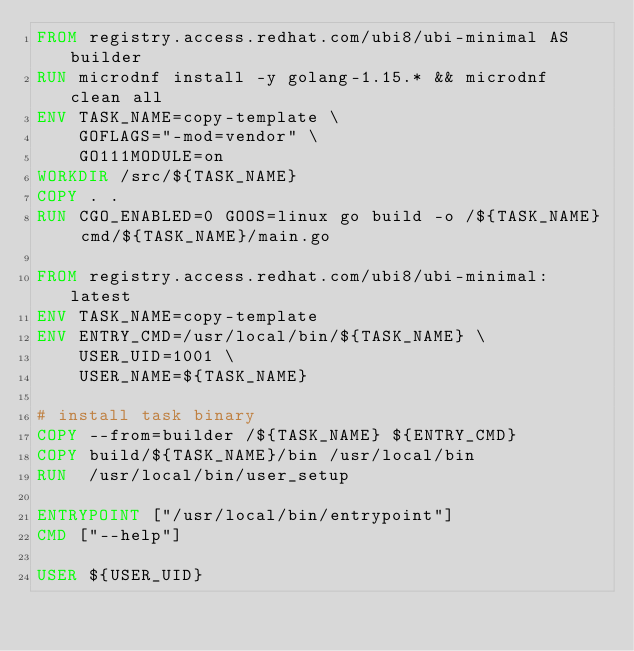Convert code to text. <code><loc_0><loc_0><loc_500><loc_500><_Dockerfile_>FROM registry.access.redhat.com/ubi8/ubi-minimal AS builder
RUN microdnf install -y golang-1.15.* && microdnf clean all
ENV TASK_NAME=copy-template \
    GOFLAGS="-mod=vendor" \
    GO111MODULE=on
WORKDIR /src/${TASK_NAME}
COPY . .
RUN	CGO_ENABLED=0 GOOS=linux go build -o /${TASK_NAME} cmd/${TASK_NAME}/main.go

FROM registry.access.redhat.com/ubi8/ubi-minimal:latest
ENV TASK_NAME=copy-template
ENV ENTRY_CMD=/usr/local/bin/${TASK_NAME} \
    USER_UID=1001 \
    USER_NAME=${TASK_NAME}

# install task binary
COPY --from=builder /${TASK_NAME} ${ENTRY_CMD}
COPY build/${TASK_NAME}/bin /usr/local/bin
RUN  /usr/local/bin/user_setup

ENTRYPOINT ["/usr/local/bin/entrypoint"]
CMD ["--help"]

USER ${USER_UID}
</code> 